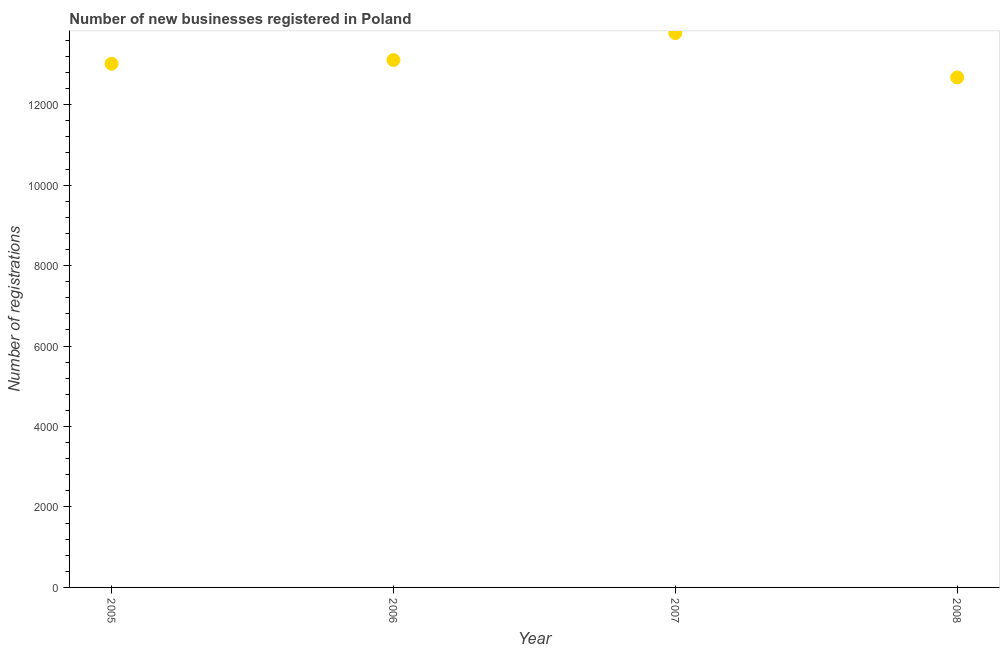What is the number of new business registrations in 2005?
Offer a terse response. 1.30e+04. Across all years, what is the maximum number of new business registrations?
Provide a succinct answer. 1.38e+04. Across all years, what is the minimum number of new business registrations?
Your answer should be very brief. 1.27e+04. What is the sum of the number of new business registrations?
Make the answer very short. 5.26e+04. What is the difference between the number of new business registrations in 2007 and 2008?
Offer a very short reply. 1103. What is the average number of new business registrations per year?
Offer a terse response. 1.31e+04. What is the median number of new business registrations?
Provide a succinct answer. 1.31e+04. Do a majority of the years between 2006 and 2005 (inclusive) have number of new business registrations greater than 10000 ?
Your response must be concise. No. What is the ratio of the number of new business registrations in 2005 to that in 2008?
Your response must be concise. 1.03. Is the number of new business registrations in 2005 less than that in 2008?
Keep it short and to the point. No. What is the difference between the highest and the second highest number of new business registrations?
Give a very brief answer. 671. Is the sum of the number of new business registrations in 2006 and 2008 greater than the maximum number of new business registrations across all years?
Your response must be concise. Yes. What is the difference between the highest and the lowest number of new business registrations?
Your answer should be very brief. 1103. Does the number of new business registrations monotonically increase over the years?
Provide a succinct answer. No. Does the graph contain grids?
Provide a short and direct response. No. What is the title of the graph?
Your answer should be compact. Number of new businesses registered in Poland. What is the label or title of the X-axis?
Your answer should be compact. Year. What is the label or title of the Y-axis?
Offer a terse response. Number of registrations. What is the Number of registrations in 2005?
Keep it short and to the point. 1.30e+04. What is the Number of registrations in 2006?
Your answer should be very brief. 1.31e+04. What is the Number of registrations in 2007?
Offer a very short reply. 1.38e+04. What is the Number of registrations in 2008?
Offer a very short reply. 1.27e+04. What is the difference between the Number of registrations in 2005 and 2006?
Your response must be concise. -92. What is the difference between the Number of registrations in 2005 and 2007?
Offer a very short reply. -763. What is the difference between the Number of registrations in 2005 and 2008?
Provide a succinct answer. 340. What is the difference between the Number of registrations in 2006 and 2007?
Your response must be concise. -671. What is the difference between the Number of registrations in 2006 and 2008?
Ensure brevity in your answer.  432. What is the difference between the Number of registrations in 2007 and 2008?
Your response must be concise. 1103. What is the ratio of the Number of registrations in 2005 to that in 2007?
Offer a terse response. 0.94. What is the ratio of the Number of registrations in 2006 to that in 2007?
Make the answer very short. 0.95. What is the ratio of the Number of registrations in 2006 to that in 2008?
Ensure brevity in your answer.  1.03. What is the ratio of the Number of registrations in 2007 to that in 2008?
Offer a terse response. 1.09. 